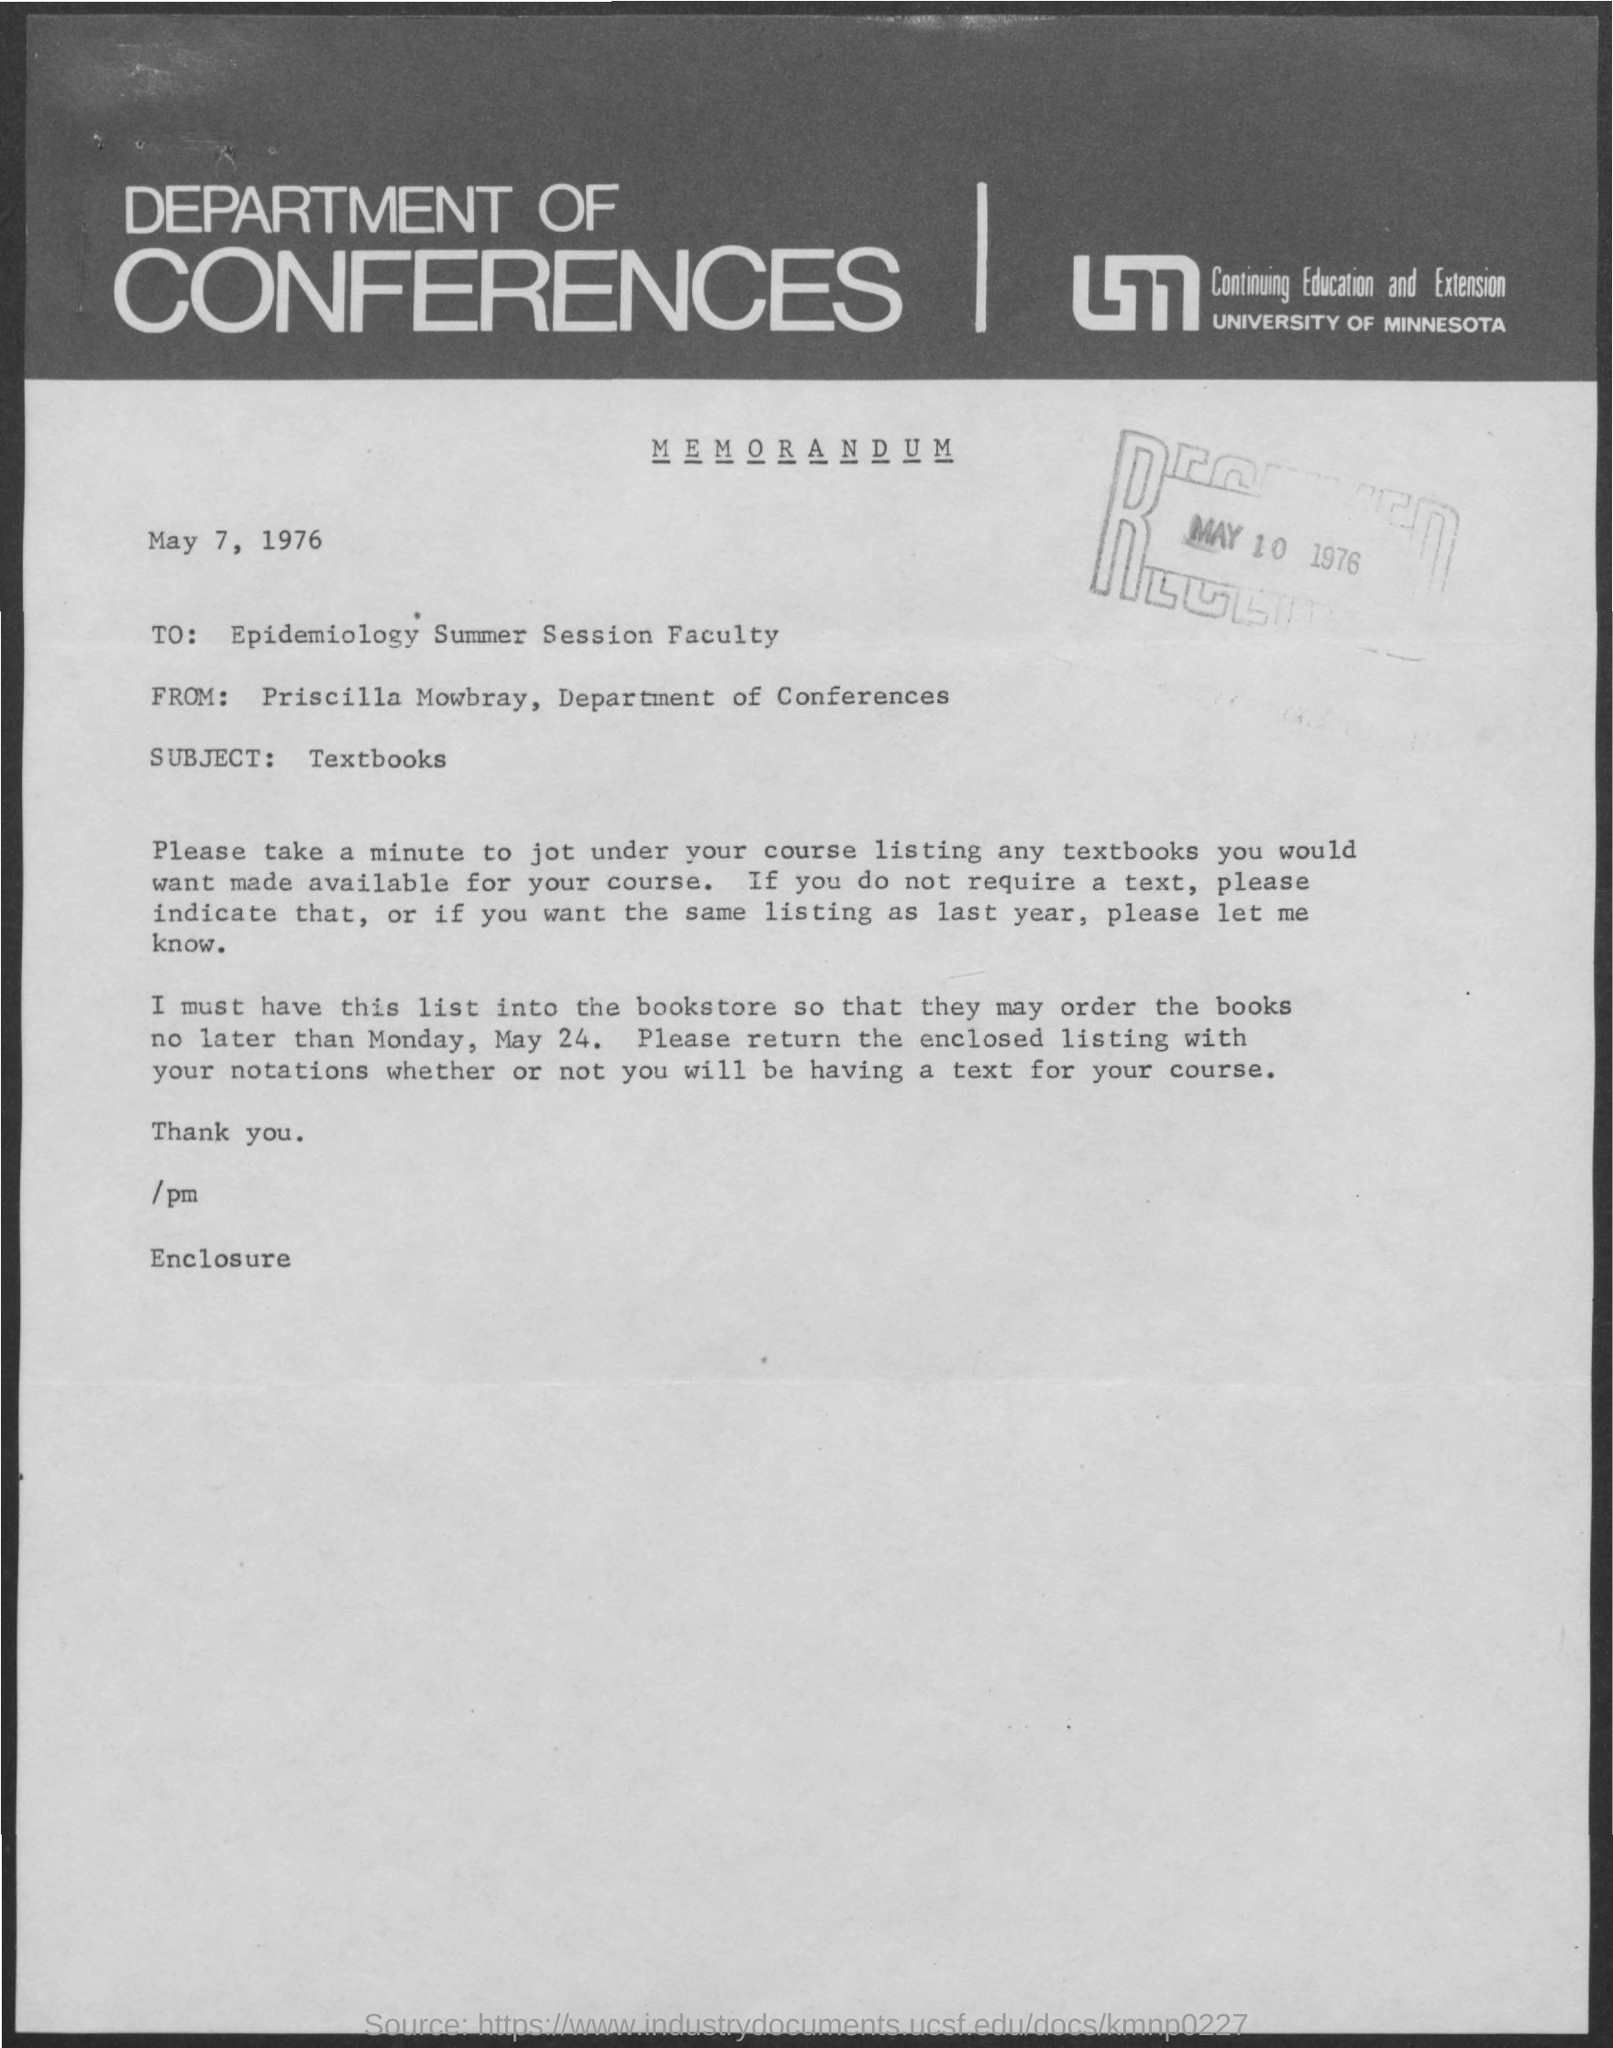What is the date on the document?
Your answer should be compact. May 7, 1976. To Whom is this memorandum addressed to?
Give a very brief answer. Epidemiology Summer Session Faculty. What is the Subject?
Your answer should be compact. TEXTBOOKS. 